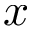Convert formula to latex. <formula><loc_0><loc_0><loc_500><loc_500>x</formula> 